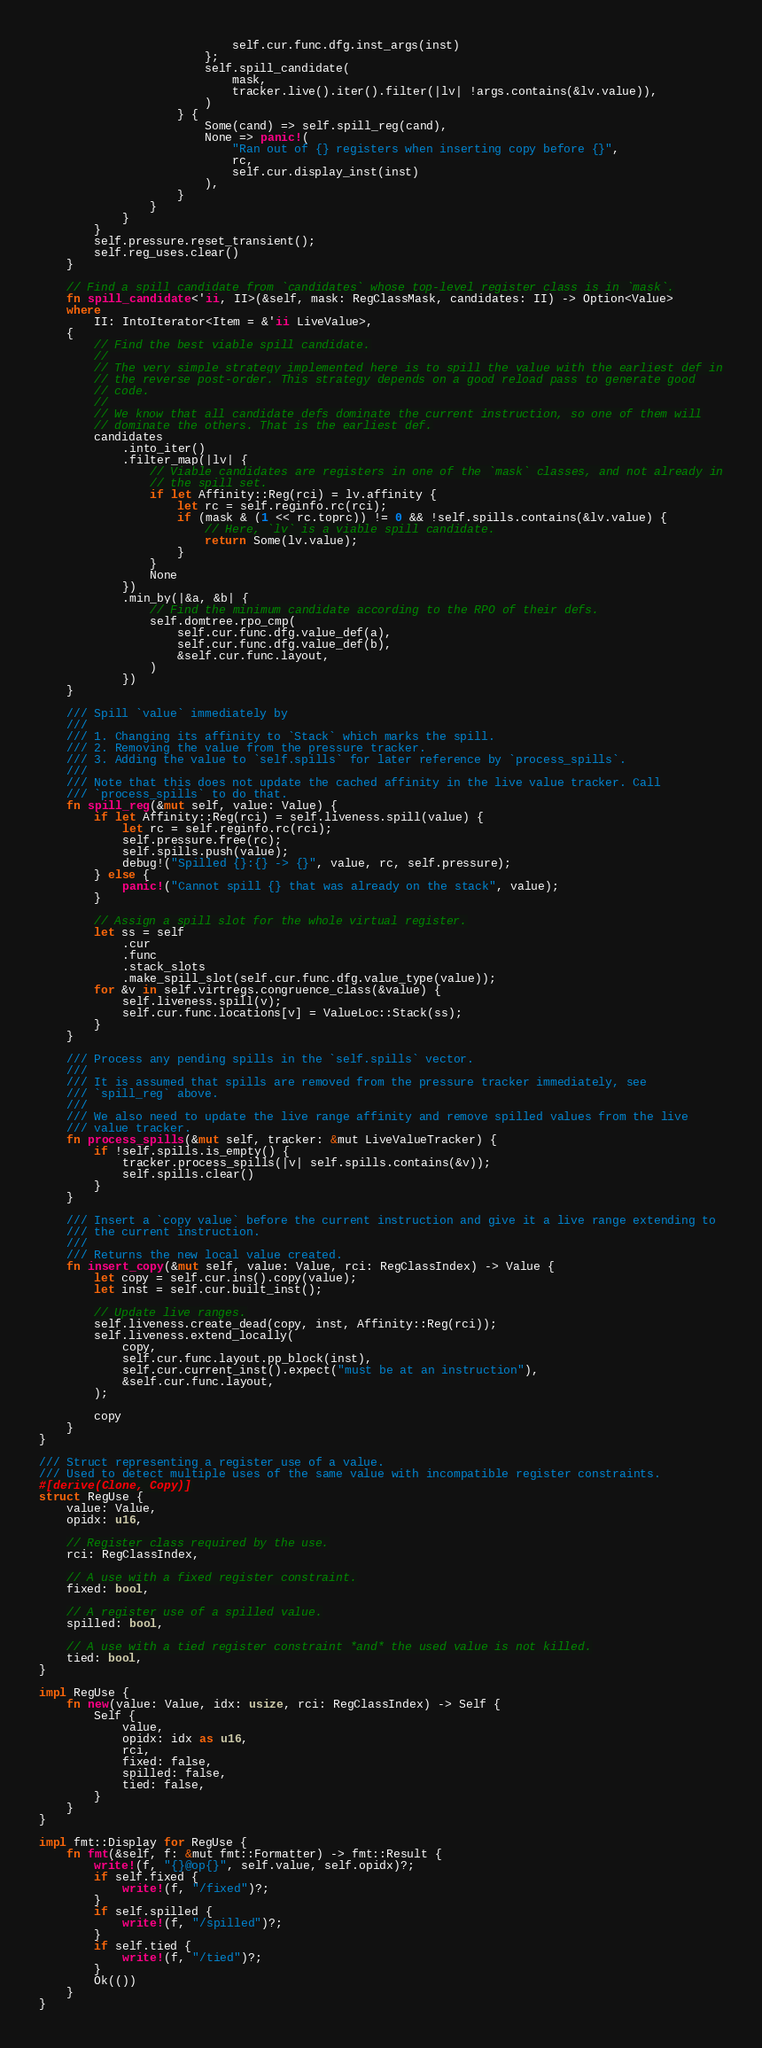<code> <loc_0><loc_0><loc_500><loc_500><_Rust_>                            self.cur.func.dfg.inst_args(inst)
                        };
                        self.spill_candidate(
                            mask,
                            tracker.live().iter().filter(|lv| !args.contains(&lv.value)),
                        )
                    } {
                        Some(cand) => self.spill_reg(cand),
                        None => panic!(
                            "Ran out of {} registers when inserting copy before {}",
                            rc,
                            self.cur.display_inst(inst)
                        ),
                    }
                }
            }
        }
        self.pressure.reset_transient();
        self.reg_uses.clear()
    }

    // Find a spill candidate from `candidates` whose top-level register class is in `mask`.
    fn spill_candidate<'ii, II>(&self, mask: RegClassMask, candidates: II) -> Option<Value>
    where
        II: IntoIterator<Item = &'ii LiveValue>,
    {
        // Find the best viable spill candidate.
        //
        // The very simple strategy implemented here is to spill the value with the earliest def in
        // the reverse post-order. This strategy depends on a good reload pass to generate good
        // code.
        //
        // We know that all candidate defs dominate the current instruction, so one of them will
        // dominate the others. That is the earliest def.
        candidates
            .into_iter()
            .filter_map(|lv| {
                // Viable candidates are registers in one of the `mask` classes, and not already in
                // the spill set.
                if let Affinity::Reg(rci) = lv.affinity {
                    let rc = self.reginfo.rc(rci);
                    if (mask & (1 << rc.toprc)) != 0 && !self.spills.contains(&lv.value) {
                        // Here, `lv` is a viable spill candidate.
                        return Some(lv.value);
                    }
                }
                None
            })
            .min_by(|&a, &b| {
                // Find the minimum candidate according to the RPO of their defs.
                self.domtree.rpo_cmp(
                    self.cur.func.dfg.value_def(a),
                    self.cur.func.dfg.value_def(b),
                    &self.cur.func.layout,
                )
            })
    }

    /// Spill `value` immediately by
    ///
    /// 1. Changing its affinity to `Stack` which marks the spill.
    /// 2. Removing the value from the pressure tracker.
    /// 3. Adding the value to `self.spills` for later reference by `process_spills`.
    ///
    /// Note that this does not update the cached affinity in the live value tracker. Call
    /// `process_spills` to do that.
    fn spill_reg(&mut self, value: Value) {
        if let Affinity::Reg(rci) = self.liveness.spill(value) {
            let rc = self.reginfo.rc(rci);
            self.pressure.free(rc);
            self.spills.push(value);
            debug!("Spilled {}:{} -> {}", value, rc, self.pressure);
        } else {
            panic!("Cannot spill {} that was already on the stack", value);
        }

        // Assign a spill slot for the whole virtual register.
        let ss = self
            .cur
            .func
            .stack_slots
            .make_spill_slot(self.cur.func.dfg.value_type(value));
        for &v in self.virtregs.congruence_class(&value) {
            self.liveness.spill(v);
            self.cur.func.locations[v] = ValueLoc::Stack(ss);
        }
    }

    /// Process any pending spills in the `self.spills` vector.
    ///
    /// It is assumed that spills are removed from the pressure tracker immediately, see
    /// `spill_reg` above.
    ///
    /// We also need to update the live range affinity and remove spilled values from the live
    /// value tracker.
    fn process_spills(&mut self, tracker: &mut LiveValueTracker) {
        if !self.spills.is_empty() {
            tracker.process_spills(|v| self.spills.contains(&v));
            self.spills.clear()
        }
    }

    /// Insert a `copy value` before the current instruction and give it a live range extending to
    /// the current instruction.
    ///
    /// Returns the new local value created.
    fn insert_copy(&mut self, value: Value, rci: RegClassIndex) -> Value {
        let copy = self.cur.ins().copy(value);
        let inst = self.cur.built_inst();

        // Update live ranges.
        self.liveness.create_dead(copy, inst, Affinity::Reg(rci));
        self.liveness.extend_locally(
            copy,
            self.cur.func.layout.pp_block(inst),
            self.cur.current_inst().expect("must be at an instruction"),
            &self.cur.func.layout,
        );

        copy
    }
}

/// Struct representing a register use of a value.
/// Used to detect multiple uses of the same value with incompatible register constraints.
#[derive(Clone, Copy)]
struct RegUse {
    value: Value,
    opidx: u16,

    // Register class required by the use.
    rci: RegClassIndex,

    // A use with a fixed register constraint.
    fixed: bool,

    // A register use of a spilled value.
    spilled: bool,

    // A use with a tied register constraint *and* the used value is not killed.
    tied: bool,
}

impl RegUse {
    fn new(value: Value, idx: usize, rci: RegClassIndex) -> Self {
        Self {
            value,
            opidx: idx as u16,
            rci,
            fixed: false,
            spilled: false,
            tied: false,
        }
    }
}

impl fmt::Display for RegUse {
    fn fmt(&self, f: &mut fmt::Formatter) -> fmt::Result {
        write!(f, "{}@op{}", self.value, self.opidx)?;
        if self.fixed {
            write!(f, "/fixed")?;
        }
        if self.spilled {
            write!(f, "/spilled")?;
        }
        if self.tied {
            write!(f, "/tied")?;
        }
        Ok(())
    }
}
</code> 